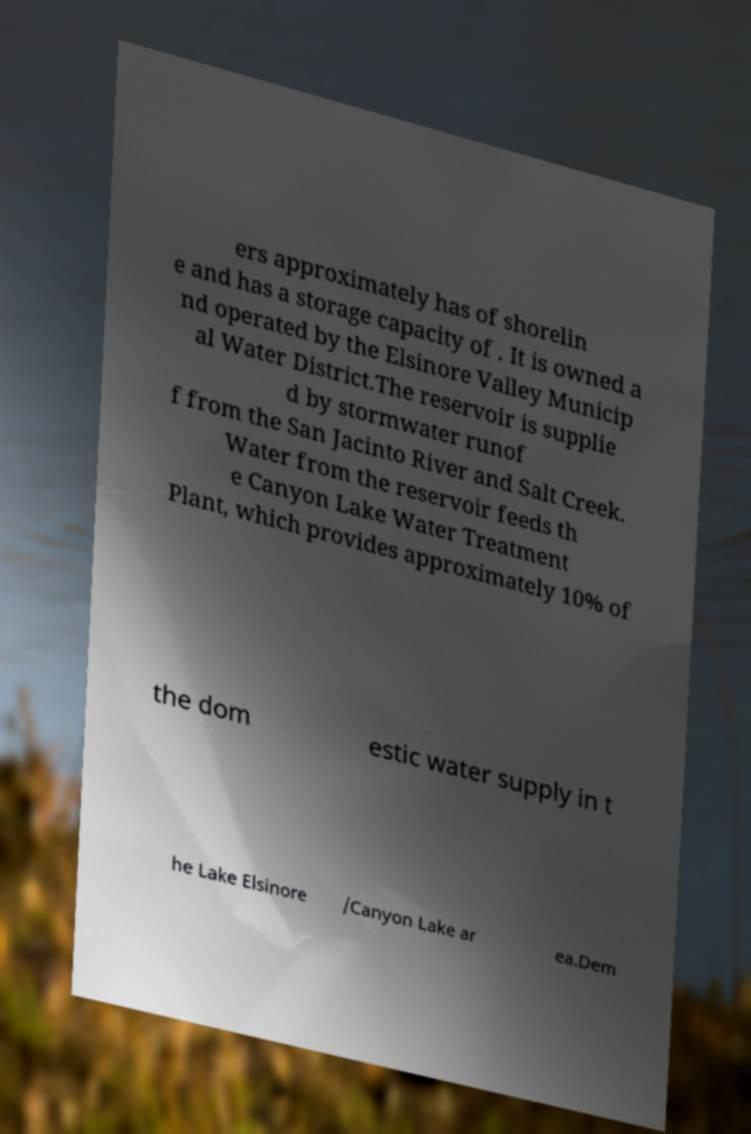What messages or text are displayed in this image? I need them in a readable, typed format. ers approximately has of shorelin e and has a storage capacity of . It is owned a nd operated by the Elsinore Valley Municip al Water District.The reservoir is supplie d by stormwater runof f from the San Jacinto River and Salt Creek. Water from the reservoir feeds th e Canyon Lake Water Treatment Plant, which provides approximately 10% of the dom estic water supply in t he Lake Elsinore /Canyon Lake ar ea.Dem 